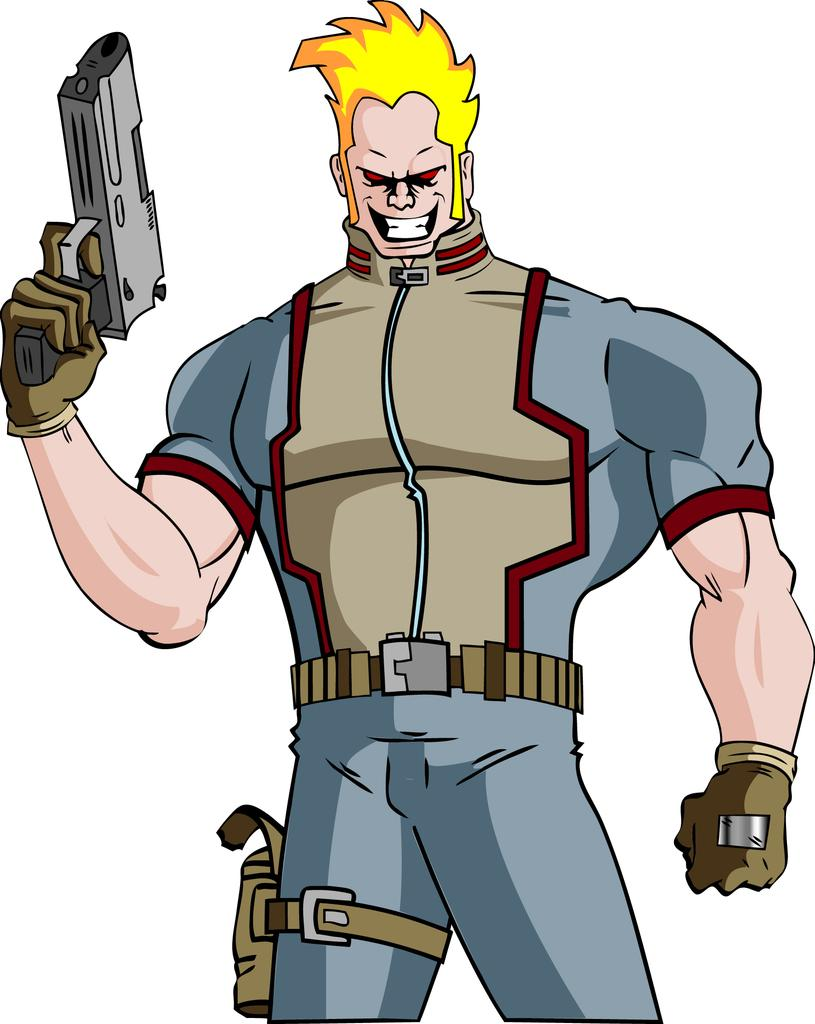What type of picture is in the image? The image contains a cartoon picture. How many trees are in the garden depicted in the cartoon picture? There is no garden or trees present in the image, as it only contains a cartoon picture. 